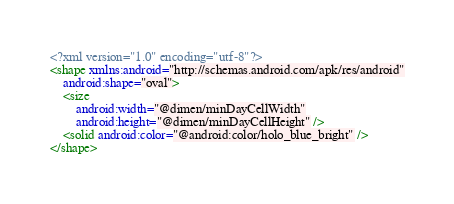<code> <loc_0><loc_0><loc_500><loc_500><_XML_><?xml version="1.0" encoding="utf-8"?>
<shape xmlns:android="http://schemas.android.com/apk/res/android"
    android:shape="oval">
    <size
        android:width="@dimen/minDayCellWidth"
        android:height="@dimen/minDayCellHeight" />
    <solid android:color="@android:color/holo_blue_bright" />
</shape>
</code> 